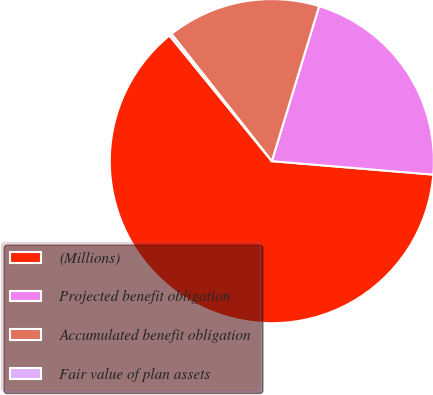Convert chart. <chart><loc_0><loc_0><loc_500><loc_500><pie_chart><fcel>(Millions)<fcel>Projected benefit obligation<fcel>Accumulated benefit obligation<fcel>Fair value of plan assets<nl><fcel>62.79%<fcel>21.61%<fcel>15.35%<fcel>0.25%<nl></chart> 